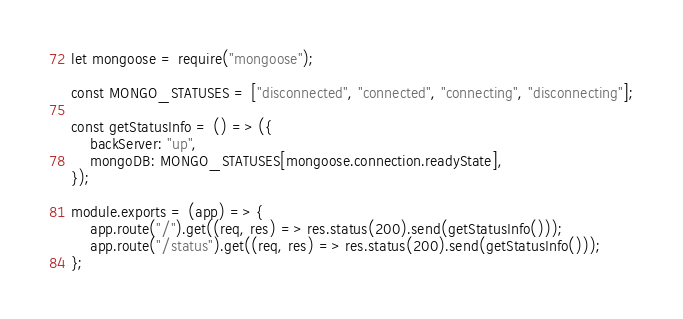<code> <loc_0><loc_0><loc_500><loc_500><_JavaScript_>let mongoose = require("mongoose");

const MONGO_STATUSES = ["disconnected", "connected", "connecting", "disconnecting"];

const getStatusInfo = () => ({
    backServer: "up",
    mongoDB: MONGO_STATUSES[mongoose.connection.readyState],
});

module.exports = (app) => {
    app.route("/").get((req, res) => res.status(200).send(getStatusInfo()));
    app.route("/status").get((req, res) => res.status(200).send(getStatusInfo()));
};
</code> 